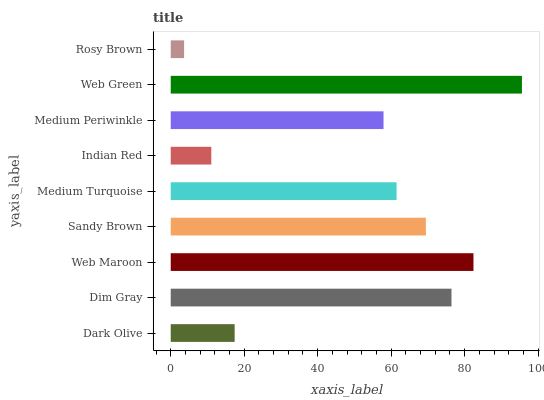Is Rosy Brown the minimum?
Answer yes or no. Yes. Is Web Green the maximum?
Answer yes or no. Yes. Is Dim Gray the minimum?
Answer yes or no. No. Is Dim Gray the maximum?
Answer yes or no. No. Is Dim Gray greater than Dark Olive?
Answer yes or no. Yes. Is Dark Olive less than Dim Gray?
Answer yes or no. Yes. Is Dark Olive greater than Dim Gray?
Answer yes or no. No. Is Dim Gray less than Dark Olive?
Answer yes or no. No. Is Medium Turquoise the high median?
Answer yes or no. Yes. Is Medium Turquoise the low median?
Answer yes or no. Yes. Is Web Green the high median?
Answer yes or no. No. Is Dark Olive the low median?
Answer yes or no. No. 